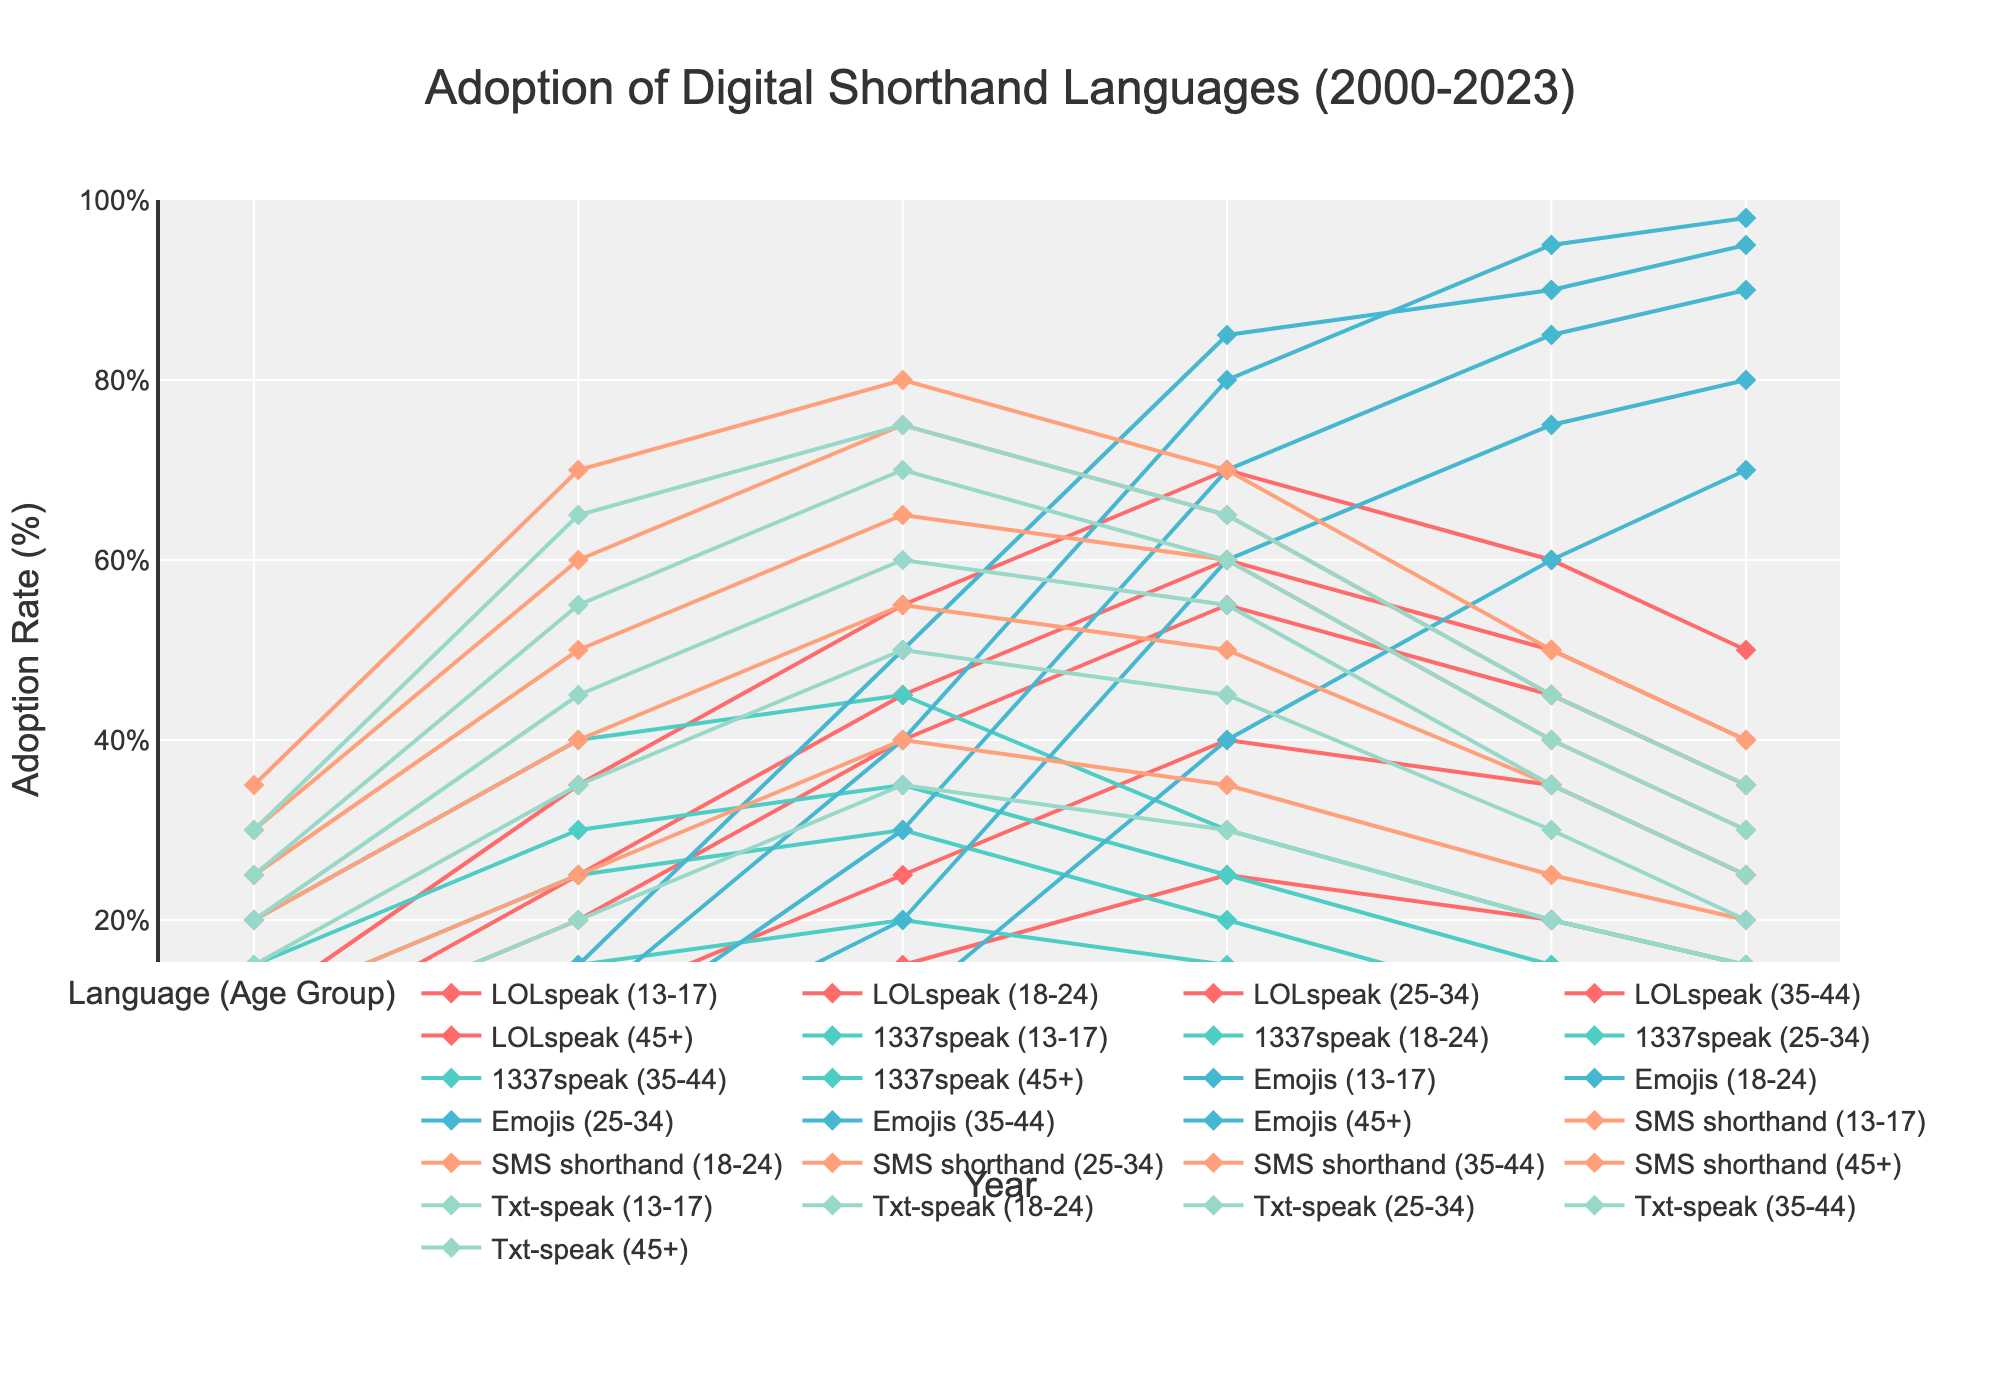What's the highest adoption rate of Emojis and in which age group and year? To find the highest adoption rate of Emojis, look for the highest point on any of the lines representing Emojis for different age groups over the years. The highest point is at 98% for the age group 13-17 in the year 2023.
Answer: 98%, 13-17, 2023 How has the adoption rate of 1337speak changed for the age group 13-17 from 2000 to 2023? Look at the 1337speak line for the age group 13-17 and note the adoption rates at the starting and ending points (15% in 2000 and 10% in 2023). The adoption rate has decreased from 15% to 10%.
Answer: Decreased Compare the adoption rates of Txt-speak and SMS shorthand for the age group 18-24 in 2010. Which one was higher and by how much? Locate the adoption rates for Txt-speak and SMS shorthand for the age group 18-24 in 2010. Txt-speak had 75%, and SMS shorthand had 80%. SMS shorthand was higher by 5%.
Answer: SMS shorthand by 5% Which digital shorthand language saw the most significant change in adoption rate for the age group 35-44 from 2010 to 2015, and what was the change? Look at the lines for the age group 35-44 from 2010 to 2015 to see the changes. Emojis saw the most significant increase from 20% to 60%, a change of 40%.
Answer: Emojis, 40% In which age group did LOLspeak peak, and what was the adoption rate? Look for the highest point among the LOLspeak lines for all age groups. The peak occurred in the age group 18-24 with an adoption rate of 70% in 2015.
Answer: 18-24, 70% Compare the adoption rates of SMS shorthand and Emojis for the age group 45+ in 2023. Which language has a higher rate and by how much? Find the adoption rates for SMS shorthand and Emojis for the age group 45+ in 2023. SMS shorthand has 20%, and Emojis have 70%. Emojis have a higher rate by 50%.
Answer: Emojis by 50% How did the adoption rate of Txt-speak change from 2000 to 2023 for the age group 25-34? Analyze the change in adoption rates from 2000 (20%) to 2023 (25%) for the age group 25-34. It declined by 25 percentage points from 25% to 0%.
Answer: Decreased by 25% Between which years did the age group 18-24 see the most significant increase in Emoji adoption rates? Track the Emoji adoption rates for the age group 18-24. The most significant increase happened between 2010 (50%) and 2015 (85%), an increase of 35%.
Answer: 2010-2015 